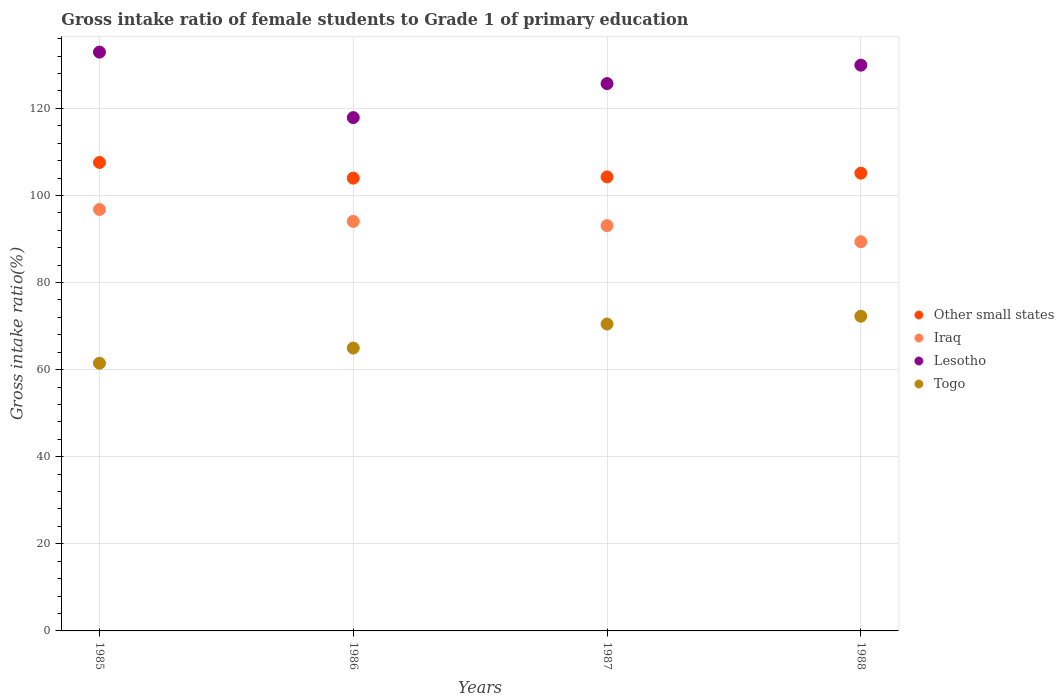Is the number of dotlines equal to the number of legend labels?
Your response must be concise. Yes. What is the gross intake ratio in Togo in 1987?
Offer a very short reply. 70.47. Across all years, what is the maximum gross intake ratio in Togo?
Your answer should be very brief. 72.26. Across all years, what is the minimum gross intake ratio in Other small states?
Provide a short and direct response. 103.97. In which year was the gross intake ratio in Togo maximum?
Offer a very short reply. 1988. In which year was the gross intake ratio in Iraq minimum?
Your response must be concise. 1988. What is the total gross intake ratio in Togo in the graph?
Provide a succinct answer. 269.15. What is the difference between the gross intake ratio in Iraq in 1985 and that in 1986?
Your response must be concise. 2.74. What is the difference between the gross intake ratio in Other small states in 1986 and the gross intake ratio in Lesotho in 1987?
Provide a short and direct response. -21.7. What is the average gross intake ratio in Other small states per year?
Your answer should be compact. 105.23. In the year 1986, what is the difference between the gross intake ratio in Togo and gross intake ratio in Other small states?
Offer a terse response. -39.02. What is the ratio of the gross intake ratio in Other small states in 1986 to that in 1987?
Offer a very short reply. 1. Is the difference between the gross intake ratio in Togo in 1987 and 1988 greater than the difference between the gross intake ratio in Other small states in 1987 and 1988?
Ensure brevity in your answer.  No. What is the difference between the highest and the second highest gross intake ratio in Togo?
Ensure brevity in your answer.  1.79. What is the difference between the highest and the lowest gross intake ratio in Togo?
Offer a terse response. 10.78. In how many years, is the gross intake ratio in Togo greater than the average gross intake ratio in Togo taken over all years?
Keep it short and to the point. 2. Does the gross intake ratio in Lesotho monotonically increase over the years?
Your answer should be compact. No. Is the gross intake ratio in Togo strictly greater than the gross intake ratio in Other small states over the years?
Ensure brevity in your answer.  No. How many years are there in the graph?
Offer a very short reply. 4. Does the graph contain grids?
Make the answer very short. Yes. How many legend labels are there?
Offer a very short reply. 4. What is the title of the graph?
Your answer should be very brief. Gross intake ratio of female students to Grade 1 of primary education. What is the label or title of the Y-axis?
Your answer should be very brief. Gross intake ratio(%). What is the Gross intake ratio(%) of Other small states in 1985?
Offer a terse response. 107.57. What is the Gross intake ratio(%) in Iraq in 1985?
Provide a succinct answer. 96.77. What is the Gross intake ratio(%) in Lesotho in 1985?
Give a very brief answer. 132.9. What is the Gross intake ratio(%) in Togo in 1985?
Your response must be concise. 61.47. What is the Gross intake ratio(%) in Other small states in 1986?
Your answer should be compact. 103.97. What is the Gross intake ratio(%) of Iraq in 1986?
Give a very brief answer. 94.04. What is the Gross intake ratio(%) in Lesotho in 1986?
Offer a terse response. 117.87. What is the Gross intake ratio(%) in Togo in 1986?
Make the answer very short. 64.95. What is the Gross intake ratio(%) of Other small states in 1987?
Give a very brief answer. 104.26. What is the Gross intake ratio(%) in Iraq in 1987?
Ensure brevity in your answer.  93.07. What is the Gross intake ratio(%) of Lesotho in 1987?
Ensure brevity in your answer.  125.68. What is the Gross intake ratio(%) in Togo in 1987?
Your answer should be compact. 70.47. What is the Gross intake ratio(%) in Other small states in 1988?
Ensure brevity in your answer.  105.11. What is the Gross intake ratio(%) of Iraq in 1988?
Make the answer very short. 89.37. What is the Gross intake ratio(%) of Lesotho in 1988?
Offer a terse response. 129.91. What is the Gross intake ratio(%) of Togo in 1988?
Your answer should be compact. 72.26. Across all years, what is the maximum Gross intake ratio(%) in Other small states?
Ensure brevity in your answer.  107.57. Across all years, what is the maximum Gross intake ratio(%) of Iraq?
Provide a succinct answer. 96.77. Across all years, what is the maximum Gross intake ratio(%) in Lesotho?
Make the answer very short. 132.9. Across all years, what is the maximum Gross intake ratio(%) in Togo?
Make the answer very short. 72.26. Across all years, what is the minimum Gross intake ratio(%) in Other small states?
Make the answer very short. 103.97. Across all years, what is the minimum Gross intake ratio(%) in Iraq?
Your answer should be very brief. 89.37. Across all years, what is the minimum Gross intake ratio(%) of Lesotho?
Offer a very short reply. 117.87. Across all years, what is the minimum Gross intake ratio(%) in Togo?
Keep it short and to the point. 61.47. What is the total Gross intake ratio(%) in Other small states in the graph?
Your response must be concise. 420.91. What is the total Gross intake ratio(%) of Iraq in the graph?
Your response must be concise. 373.25. What is the total Gross intake ratio(%) of Lesotho in the graph?
Keep it short and to the point. 506.36. What is the total Gross intake ratio(%) in Togo in the graph?
Offer a terse response. 269.15. What is the difference between the Gross intake ratio(%) of Other small states in 1985 and that in 1986?
Ensure brevity in your answer.  3.6. What is the difference between the Gross intake ratio(%) in Iraq in 1985 and that in 1986?
Provide a short and direct response. 2.74. What is the difference between the Gross intake ratio(%) in Lesotho in 1985 and that in 1986?
Give a very brief answer. 15.04. What is the difference between the Gross intake ratio(%) of Togo in 1985 and that in 1986?
Ensure brevity in your answer.  -3.48. What is the difference between the Gross intake ratio(%) of Other small states in 1985 and that in 1987?
Ensure brevity in your answer.  3.32. What is the difference between the Gross intake ratio(%) of Iraq in 1985 and that in 1987?
Provide a succinct answer. 3.71. What is the difference between the Gross intake ratio(%) of Lesotho in 1985 and that in 1987?
Keep it short and to the point. 7.23. What is the difference between the Gross intake ratio(%) in Togo in 1985 and that in 1987?
Your response must be concise. -8.99. What is the difference between the Gross intake ratio(%) in Other small states in 1985 and that in 1988?
Offer a very short reply. 2.46. What is the difference between the Gross intake ratio(%) of Iraq in 1985 and that in 1988?
Give a very brief answer. 7.4. What is the difference between the Gross intake ratio(%) in Lesotho in 1985 and that in 1988?
Make the answer very short. 2.99. What is the difference between the Gross intake ratio(%) in Togo in 1985 and that in 1988?
Offer a terse response. -10.78. What is the difference between the Gross intake ratio(%) in Other small states in 1986 and that in 1987?
Your answer should be very brief. -0.29. What is the difference between the Gross intake ratio(%) of Iraq in 1986 and that in 1987?
Your answer should be compact. 0.97. What is the difference between the Gross intake ratio(%) of Lesotho in 1986 and that in 1987?
Provide a short and direct response. -7.81. What is the difference between the Gross intake ratio(%) of Togo in 1986 and that in 1987?
Provide a short and direct response. -5.52. What is the difference between the Gross intake ratio(%) in Other small states in 1986 and that in 1988?
Provide a succinct answer. -1.14. What is the difference between the Gross intake ratio(%) in Iraq in 1986 and that in 1988?
Provide a short and direct response. 4.67. What is the difference between the Gross intake ratio(%) in Lesotho in 1986 and that in 1988?
Offer a very short reply. -12.05. What is the difference between the Gross intake ratio(%) of Togo in 1986 and that in 1988?
Your answer should be very brief. -7.3. What is the difference between the Gross intake ratio(%) in Other small states in 1987 and that in 1988?
Your response must be concise. -0.85. What is the difference between the Gross intake ratio(%) in Iraq in 1987 and that in 1988?
Your answer should be very brief. 3.69. What is the difference between the Gross intake ratio(%) of Lesotho in 1987 and that in 1988?
Offer a very short reply. -4.24. What is the difference between the Gross intake ratio(%) of Togo in 1987 and that in 1988?
Give a very brief answer. -1.79. What is the difference between the Gross intake ratio(%) in Other small states in 1985 and the Gross intake ratio(%) in Iraq in 1986?
Offer a very short reply. 13.54. What is the difference between the Gross intake ratio(%) in Other small states in 1985 and the Gross intake ratio(%) in Lesotho in 1986?
Offer a very short reply. -10.29. What is the difference between the Gross intake ratio(%) in Other small states in 1985 and the Gross intake ratio(%) in Togo in 1986?
Give a very brief answer. 42.62. What is the difference between the Gross intake ratio(%) in Iraq in 1985 and the Gross intake ratio(%) in Lesotho in 1986?
Offer a very short reply. -21.09. What is the difference between the Gross intake ratio(%) of Iraq in 1985 and the Gross intake ratio(%) of Togo in 1986?
Offer a terse response. 31.82. What is the difference between the Gross intake ratio(%) in Lesotho in 1985 and the Gross intake ratio(%) in Togo in 1986?
Make the answer very short. 67.95. What is the difference between the Gross intake ratio(%) of Other small states in 1985 and the Gross intake ratio(%) of Iraq in 1987?
Keep it short and to the point. 14.51. What is the difference between the Gross intake ratio(%) in Other small states in 1985 and the Gross intake ratio(%) in Lesotho in 1987?
Offer a very short reply. -18.1. What is the difference between the Gross intake ratio(%) in Other small states in 1985 and the Gross intake ratio(%) in Togo in 1987?
Give a very brief answer. 37.1. What is the difference between the Gross intake ratio(%) in Iraq in 1985 and the Gross intake ratio(%) in Lesotho in 1987?
Your answer should be compact. -28.9. What is the difference between the Gross intake ratio(%) in Iraq in 1985 and the Gross intake ratio(%) in Togo in 1987?
Give a very brief answer. 26.31. What is the difference between the Gross intake ratio(%) of Lesotho in 1985 and the Gross intake ratio(%) of Togo in 1987?
Provide a short and direct response. 62.44. What is the difference between the Gross intake ratio(%) of Other small states in 1985 and the Gross intake ratio(%) of Iraq in 1988?
Keep it short and to the point. 18.2. What is the difference between the Gross intake ratio(%) of Other small states in 1985 and the Gross intake ratio(%) of Lesotho in 1988?
Offer a very short reply. -22.34. What is the difference between the Gross intake ratio(%) of Other small states in 1985 and the Gross intake ratio(%) of Togo in 1988?
Provide a short and direct response. 35.32. What is the difference between the Gross intake ratio(%) of Iraq in 1985 and the Gross intake ratio(%) of Lesotho in 1988?
Ensure brevity in your answer.  -33.14. What is the difference between the Gross intake ratio(%) of Iraq in 1985 and the Gross intake ratio(%) of Togo in 1988?
Give a very brief answer. 24.52. What is the difference between the Gross intake ratio(%) of Lesotho in 1985 and the Gross intake ratio(%) of Togo in 1988?
Your answer should be compact. 60.65. What is the difference between the Gross intake ratio(%) in Other small states in 1986 and the Gross intake ratio(%) in Iraq in 1987?
Keep it short and to the point. 10.91. What is the difference between the Gross intake ratio(%) in Other small states in 1986 and the Gross intake ratio(%) in Lesotho in 1987?
Your answer should be very brief. -21.7. What is the difference between the Gross intake ratio(%) in Other small states in 1986 and the Gross intake ratio(%) in Togo in 1987?
Offer a very short reply. 33.5. What is the difference between the Gross intake ratio(%) in Iraq in 1986 and the Gross intake ratio(%) in Lesotho in 1987?
Offer a terse response. -31.64. What is the difference between the Gross intake ratio(%) of Iraq in 1986 and the Gross intake ratio(%) of Togo in 1987?
Provide a short and direct response. 23.57. What is the difference between the Gross intake ratio(%) of Lesotho in 1986 and the Gross intake ratio(%) of Togo in 1987?
Your answer should be compact. 47.4. What is the difference between the Gross intake ratio(%) of Other small states in 1986 and the Gross intake ratio(%) of Iraq in 1988?
Your answer should be compact. 14.6. What is the difference between the Gross intake ratio(%) in Other small states in 1986 and the Gross intake ratio(%) in Lesotho in 1988?
Your response must be concise. -25.94. What is the difference between the Gross intake ratio(%) in Other small states in 1986 and the Gross intake ratio(%) in Togo in 1988?
Offer a terse response. 31.71. What is the difference between the Gross intake ratio(%) in Iraq in 1986 and the Gross intake ratio(%) in Lesotho in 1988?
Your response must be concise. -35.88. What is the difference between the Gross intake ratio(%) in Iraq in 1986 and the Gross intake ratio(%) in Togo in 1988?
Your answer should be compact. 21.78. What is the difference between the Gross intake ratio(%) of Lesotho in 1986 and the Gross intake ratio(%) of Togo in 1988?
Your response must be concise. 45.61. What is the difference between the Gross intake ratio(%) of Other small states in 1987 and the Gross intake ratio(%) of Iraq in 1988?
Give a very brief answer. 14.88. What is the difference between the Gross intake ratio(%) of Other small states in 1987 and the Gross intake ratio(%) of Lesotho in 1988?
Provide a short and direct response. -25.66. What is the difference between the Gross intake ratio(%) in Other small states in 1987 and the Gross intake ratio(%) in Togo in 1988?
Provide a short and direct response. 32. What is the difference between the Gross intake ratio(%) of Iraq in 1987 and the Gross intake ratio(%) of Lesotho in 1988?
Your answer should be compact. -36.85. What is the difference between the Gross intake ratio(%) of Iraq in 1987 and the Gross intake ratio(%) of Togo in 1988?
Offer a very short reply. 20.81. What is the difference between the Gross intake ratio(%) in Lesotho in 1987 and the Gross intake ratio(%) in Togo in 1988?
Ensure brevity in your answer.  53.42. What is the average Gross intake ratio(%) of Other small states per year?
Give a very brief answer. 105.23. What is the average Gross intake ratio(%) in Iraq per year?
Give a very brief answer. 93.31. What is the average Gross intake ratio(%) in Lesotho per year?
Offer a terse response. 126.59. What is the average Gross intake ratio(%) of Togo per year?
Your response must be concise. 67.29. In the year 1985, what is the difference between the Gross intake ratio(%) of Other small states and Gross intake ratio(%) of Iraq?
Offer a terse response. 10.8. In the year 1985, what is the difference between the Gross intake ratio(%) in Other small states and Gross intake ratio(%) in Lesotho?
Ensure brevity in your answer.  -25.33. In the year 1985, what is the difference between the Gross intake ratio(%) of Other small states and Gross intake ratio(%) of Togo?
Give a very brief answer. 46.1. In the year 1985, what is the difference between the Gross intake ratio(%) in Iraq and Gross intake ratio(%) in Lesotho?
Keep it short and to the point. -36.13. In the year 1985, what is the difference between the Gross intake ratio(%) in Iraq and Gross intake ratio(%) in Togo?
Ensure brevity in your answer.  35.3. In the year 1985, what is the difference between the Gross intake ratio(%) in Lesotho and Gross intake ratio(%) in Togo?
Ensure brevity in your answer.  71.43. In the year 1986, what is the difference between the Gross intake ratio(%) of Other small states and Gross intake ratio(%) of Iraq?
Provide a short and direct response. 9.93. In the year 1986, what is the difference between the Gross intake ratio(%) of Other small states and Gross intake ratio(%) of Lesotho?
Offer a very short reply. -13.9. In the year 1986, what is the difference between the Gross intake ratio(%) in Other small states and Gross intake ratio(%) in Togo?
Ensure brevity in your answer.  39.02. In the year 1986, what is the difference between the Gross intake ratio(%) of Iraq and Gross intake ratio(%) of Lesotho?
Your answer should be compact. -23.83. In the year 1986, what is the difference between the Gross intake ratio(%) in Iraq and Gross intake ratio(%) in Togo?
Offer a terse response. 29.09. In the year 1986, what is the difference between the Gross intake ratio(%) in Lesotho and Gross intake ratio(%) in Togo?
Provide a succinct answer. 52.91. In the year 1987, what is the difference between the Gross intake ratio(%) of Other small states and Gross intake ratio(%) of Iraq?
Make the answer very short. 11.19. In the year 1987, what is the difference between the Gross intake ratio(%) in Other small states and Gross intake ratio(%) in Lesotho?
Offer a terse response. -21.42. In the year 1987, what is the difference between the Gross intake ratio(%) in Other small states and Gross intake ratio(%) in Togo?
Your answer should be compact. 33.79. In the year 1987, what is the difference between the Gross intake ratio(%) of Iraq and Gross intake ratio(%) of Lesotho?
Ensure brevity in your answer.  -32.61. In the year 1987, what is the difference between the Gross intake ratio(%) of Iraq and Gross intake ratio(%) of Togo?
Give a very brief answer. 22.6. In the year 1987, what is the difference between the Gross intake ratio(%) of Lesotho and Gross intake ratio(%) of Togo?
Provide a short and direct response. 55.21. In the year 1988, what is the difference between the Gross intake ratio(%) of Other small states and Gross intake ratio(%) of Iraq?
Keep it short and to the point. 15.74. In the year 1988, what is the difference between the Gross intake ratio(%) in Other small states and Gross intake ratio(%) in Lesotho?
Give a very brief answer. -24.8. In the year 1988, what is the difference between the Gross intake ratio(%) in Other small states and Gross intake ratio(%) in Togo?
Make the answer very short. 32.85. In the year 1988, what is the difference between the Gross intake ratio(%) of Iraq and Gross intake ratio(%) of Lesotho?
Ensure brevity in your answer.  -40.54. In the year 1988, what is the difference between the Gross intake ratio(%) in Iraq and Gross intake ratio(%) in Togo?
Offer a terse response. 17.12. In the year 1988, what is the difference between the Gross intake ratio(%) of Lesotho and Gross intake ratio(%) of Togo?
Your answer should be very brief. 57.66. What is the ratio of the Gross intake ratio(%) in Other small states in 1985 to that in 1986?
Give a very brief answer. 1.03. What is the ratio of the Gross intake ratio(%) in Iraq in 1985 to that in 1986?
Provide a succinct answer. 1.03. What is the ratio of the Gross intake ratio(%) in Lesotho in 1985 to that in 1986?
Provide a succinct answer. 1.13. What is the ratio of the Gross intake ratio(%) of Togo in 1985 to that in 1986?
Provide a short and direct response. 0.95. What is the ratio of the Gross intake ratio(%) of Other small states in 1985 to that in 1987?
Keep it short and to the point. 1.03. What is the ratio of the Gross intake ratio(%) of Iraq in 1985 to that in 1987?
Give a very brief answer. 1.04. What is the ratio of the Gross intake ratio(%) in Lesotho in 1985 to that in 1987?
Give a very brief answer. 1.06. What is the ratio of the Gross intake ratio(%) of Togo in 1985 to that in 1987?
Offer a terse response. 0.87. What is the ratio of the Gross intake ratio(%) in Other small states in 1985 to that in 1988?
Your answer should be very brief. 1.02. What is the ratio of the Gross intake ratio(%) of Iraq in 1985 to that in 1988?
Your answer should be compact. 1.08. What is the ratio of the Gross intake ratio(%) of Lesotho in 1985 to that in 1988?
Ensure brevity in your answer.  1.02. What is the ratio of the Gross intake ratio(%) in Togo in 1985 to that in 1988?
Your answer should be very brief. 0.85. What is the ratio of the Gross intake ratio(%) of Other small states in 1986 to that in 1987?
Ensure brevity in your answer.  1. What is the ratio of the Gross intake ratio(%) in Iraq in 1986 to that in 1987?
Offer a very short reply. 1.01. What is the ratio of the Gross intake ratio(%) in Lesotho in 1986 to that in 1987?
Offer a terse response. 0.94. What is the ratio of the Gross intake ratio(%) in Togo in 1986 to that in 1987?
Your answer should be compact. 0.92. What is the ratio of the Gross intake ratio(%) of Iraq in 1986 to that in 1988?
Keep it short and to the point. 1.05. What is the ratio of the Gross intake ratio(%) in Lesotho in 1986 to that in 1988?
Your response must be concise. 0.91. What is the ratio of the Gross intake ratio(%) of Togo in 1986 to that in 1988?
Offer a very short reply. 0.9. What is the ratio of the Gross intake ratio(%) in Other small states in 1987 to that in 1988?
Your response must be concise. 0.99. What is the ratio of the Gross intake ratio(%) of Iraq in 1987 to that in 1988?
Offer a very short reply. 1.04. What is the ratio of the Gross intake ratio(%) of Lesotho in 1987 to that in 1988?
Your answer should be compact. 0.97. What is the ratio of the Gross intake ratio(%) in Togo in 1987 to that in 1988?
Offer a very short reply. 0.98. What is the difference between the highest and the second highest Gross intake ratio(%) of Other small states?
Provide a succinct answer. 2.46. What is the difference between the highest and the second highest Gross intake ratio(%) in Iraq?
Offer a very short reply. 2.74. What is the difference between the highest and the second highest Gross intake ratio(%) of Lesotho?
Ensure brevity in your answer.  2.99. What is the difference between the highest and the second highest Gross intake ratio(%) in Togo?
Provide a short and direct response. 1.79. What is the difference between the highest and the lowest Gross intake ratio(%) in Other small states?
Offer a terse response. 3.6. What is the difference between the highest and the lowest Gross intake ratio(%) of Iraq?
Give a very brief answer. 7.4. What is the difference between the highest and the lowest Gross intake ratio(%) in Lesotho?
Your answer should be very brief. 15.04. What is the difference between the highest and the lowest Gross intake ratio(%) in Togo?
Keep it short and to the point. 10.78. 